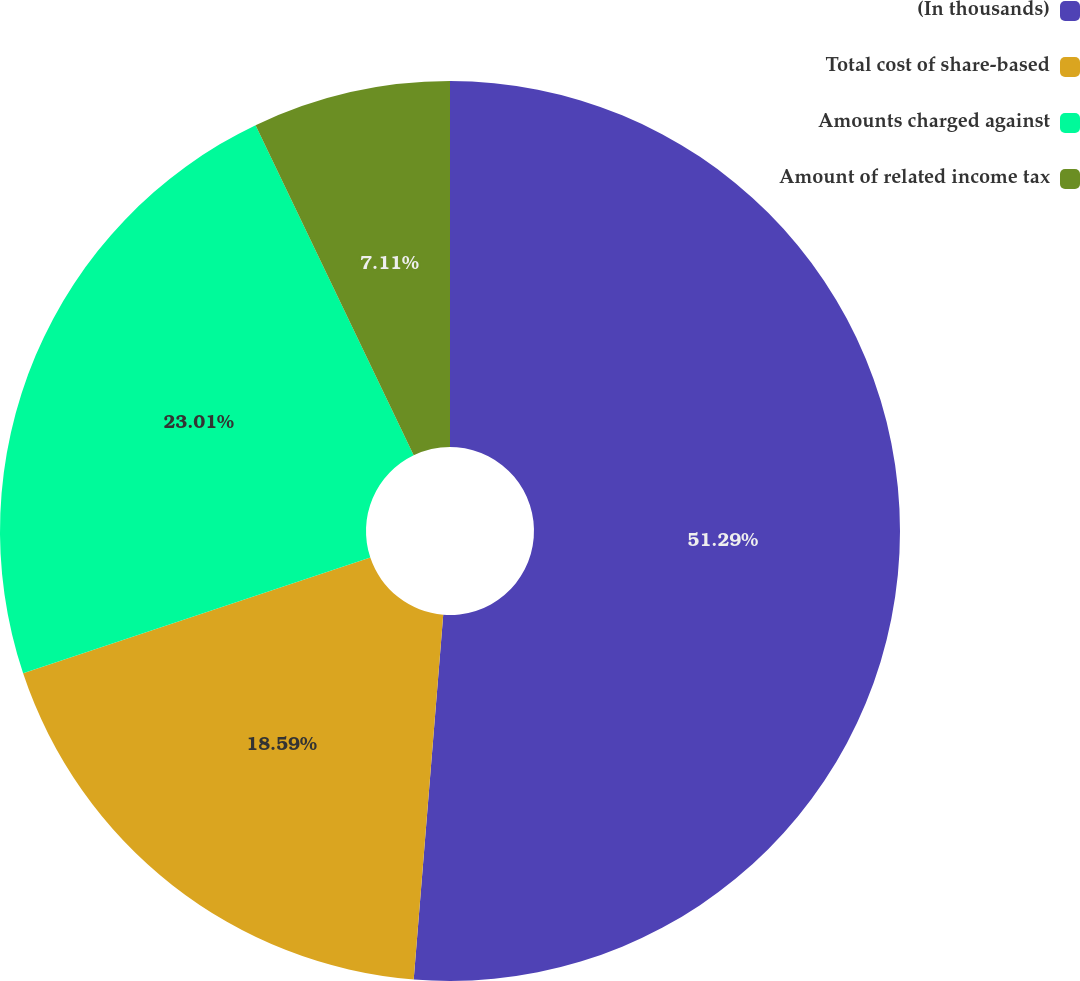<chart> <loc_0><loc_0><loc_500><loc_500><pie_chart><fcel>(In thousands)<fcel>Total cost of share-based<fcel>Amounts charged against<fcel>Amount of related income tax<nl><fcel>51.28%<fcel>18.59%<fcel>23.01%<fcel>7.11%<nl></chart> 